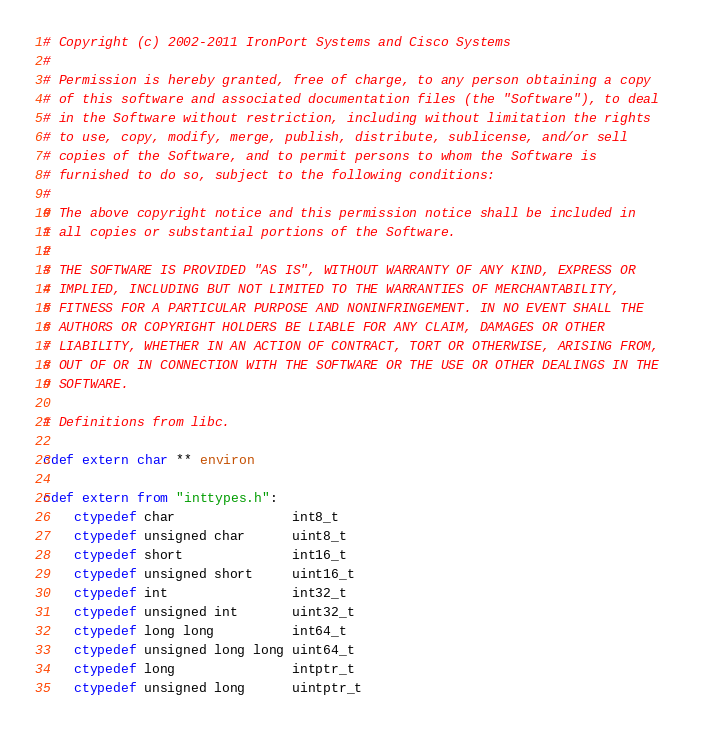<code> <loc_0><loc_0><loc_500><loc_500><_Cython_># Copyright (c) 2002-2011 IronPort Systems and Cisco Systems
#
# Permission is hereby granted, free of charge, to any person obtaining a copy  
# of this software and associated documentation files (the "Software"), to deal
# in the Software without restriction, including without limitation the rights  
# to use, copy, modify, merge, publish, distribute, sublicense, and/or sell 
# copies of the Software, and to permit persons to whom the Software is 
# furnished to do so, subject to the following conditions:
#
# The above copyright notice and this permission notice shall be included in 
# all copies or substantial portions of the Software.
#
# THE SOFTWARE IS PROVIDED "AS IS", WITHOUT WARRANTY OF ANY KIND, EXPRESS OR 
# IMPLIED, INCLUDING BUT NOT LIMITED TO THE WARRANTIES OF MERCHANTABILITY, 
# FITNESS FOR A PARTICULAR PURPOSE AND NONINFRINGEMENT. IN NO EVENT SHALL THE 
# AUTHORS OR COPYRIGHT HOLDERS BE LIABLE FOR ANY CLAIM, DAMAGES OR OTHER 
# LIABILITY, WHETHER IN AN ACTION OF CONTRACT, TORT OR OTHERWISE, ARISING FROM,
# OUT OF OR IN CONNECTION WITH THE SOFTWARE OR THE USE OR OTHER DEALINGS IN THE
# SOFTWARE.

# Definitions from libc.

cdef extern char ** environ

cdef extern from "inttypes.h":
    ctypedef char               int8_t
    ctypedef unsigned char      uint8_t
    ctypedef short              int16_t
    ctypedef unsigned short     uint16_t
    ctypedef int                int32_t
    ctypedef unsigned int       uint32_t
    ctypedef long long          int64_t
    ctypedef unsigned long long uint64_t
    ctypedef long               intptr_t
    ctypedef unsigned long      uintptr_t
</code> 